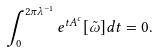<formula> <loc_0><loc_0><loc_500><loc_500>\int _ { 0 } ^ { 2 \pi \lambda ^ { - 1 } } e ^ { t A ^ { c } } [ \tilde { \omega } ] d t = 0 .</formula> 